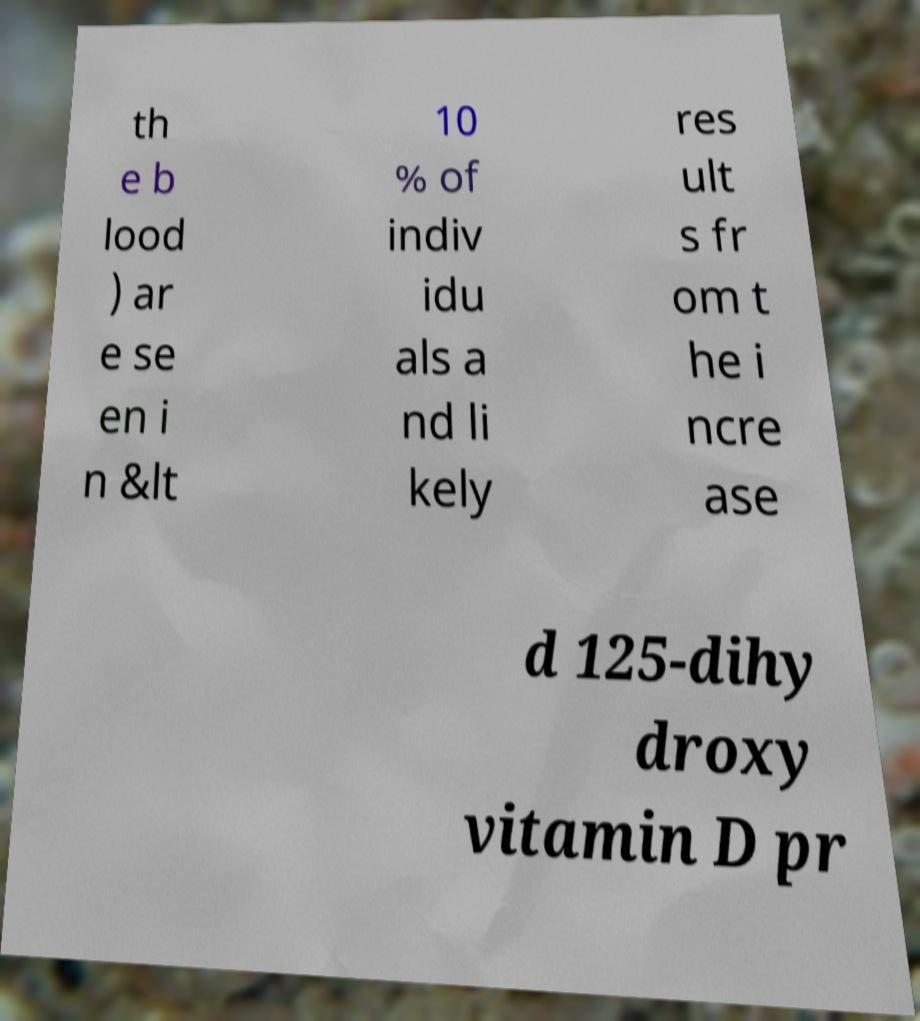Can you read and provide the text displayed in the image?This photo seems to have some interesting text. Can you extract and type it out for me? th e b lood ) ar e se en i n &lt 10 % of indiv idu als a nd li kely res ult s fr om t he i ncre ase d 125-dihy droxy vitamin D pr 